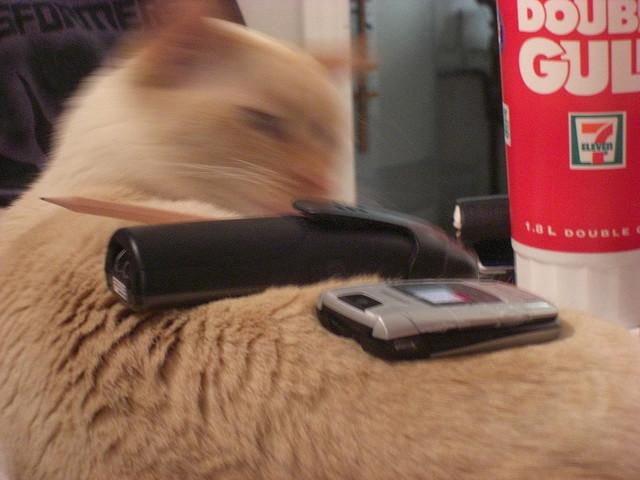What animal is this?
Concise answer only. Cat. Where was the soda in the cup purchased?
Keep it brief. 7 eleven. What are these?
Be succinct. Phones. 